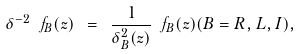Convert formula to latex. <formula><loc_0><loc_0><loc_500><loc_500>\delta ^ { - 2 } \ f _ { B } ( z ) \ = \ \frac { 1 } { \delta ^ { 2 } _ { B } ( z ) } \ f _ { B } ( z ) ( B = R , L , I ) ,</formula> 